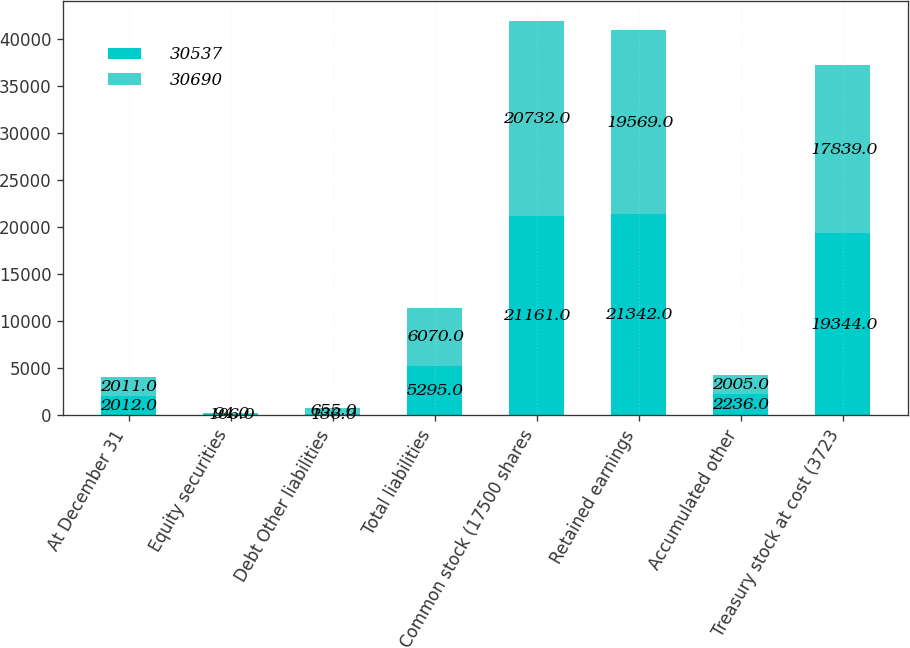<chart> <loc_0><loc_0><loc_500><loc_500><stacked_bar_chart><ecel><fcel>At December 31<fcel>Equity securities<fcel>Debt Other liabilities<fcel>Total liabilities<fcel>Common stock (17500 shares<fcel>Retained earnings<fcel>Accumulated other<fcel>Treasury stock at cost (3723<nl><fcel>30537<fcel>2012<fcel>106<fcel>136<fcel>5295<fcel>21161<fcel>21342<fcel>2236<fcel>19344<nl><fcel>30690<fcel>2011<fcel>94<fcel>655<fcel>6070<fcel>20732<fcel>19569<fcel>2005<fcel>17839<nl></chart> 